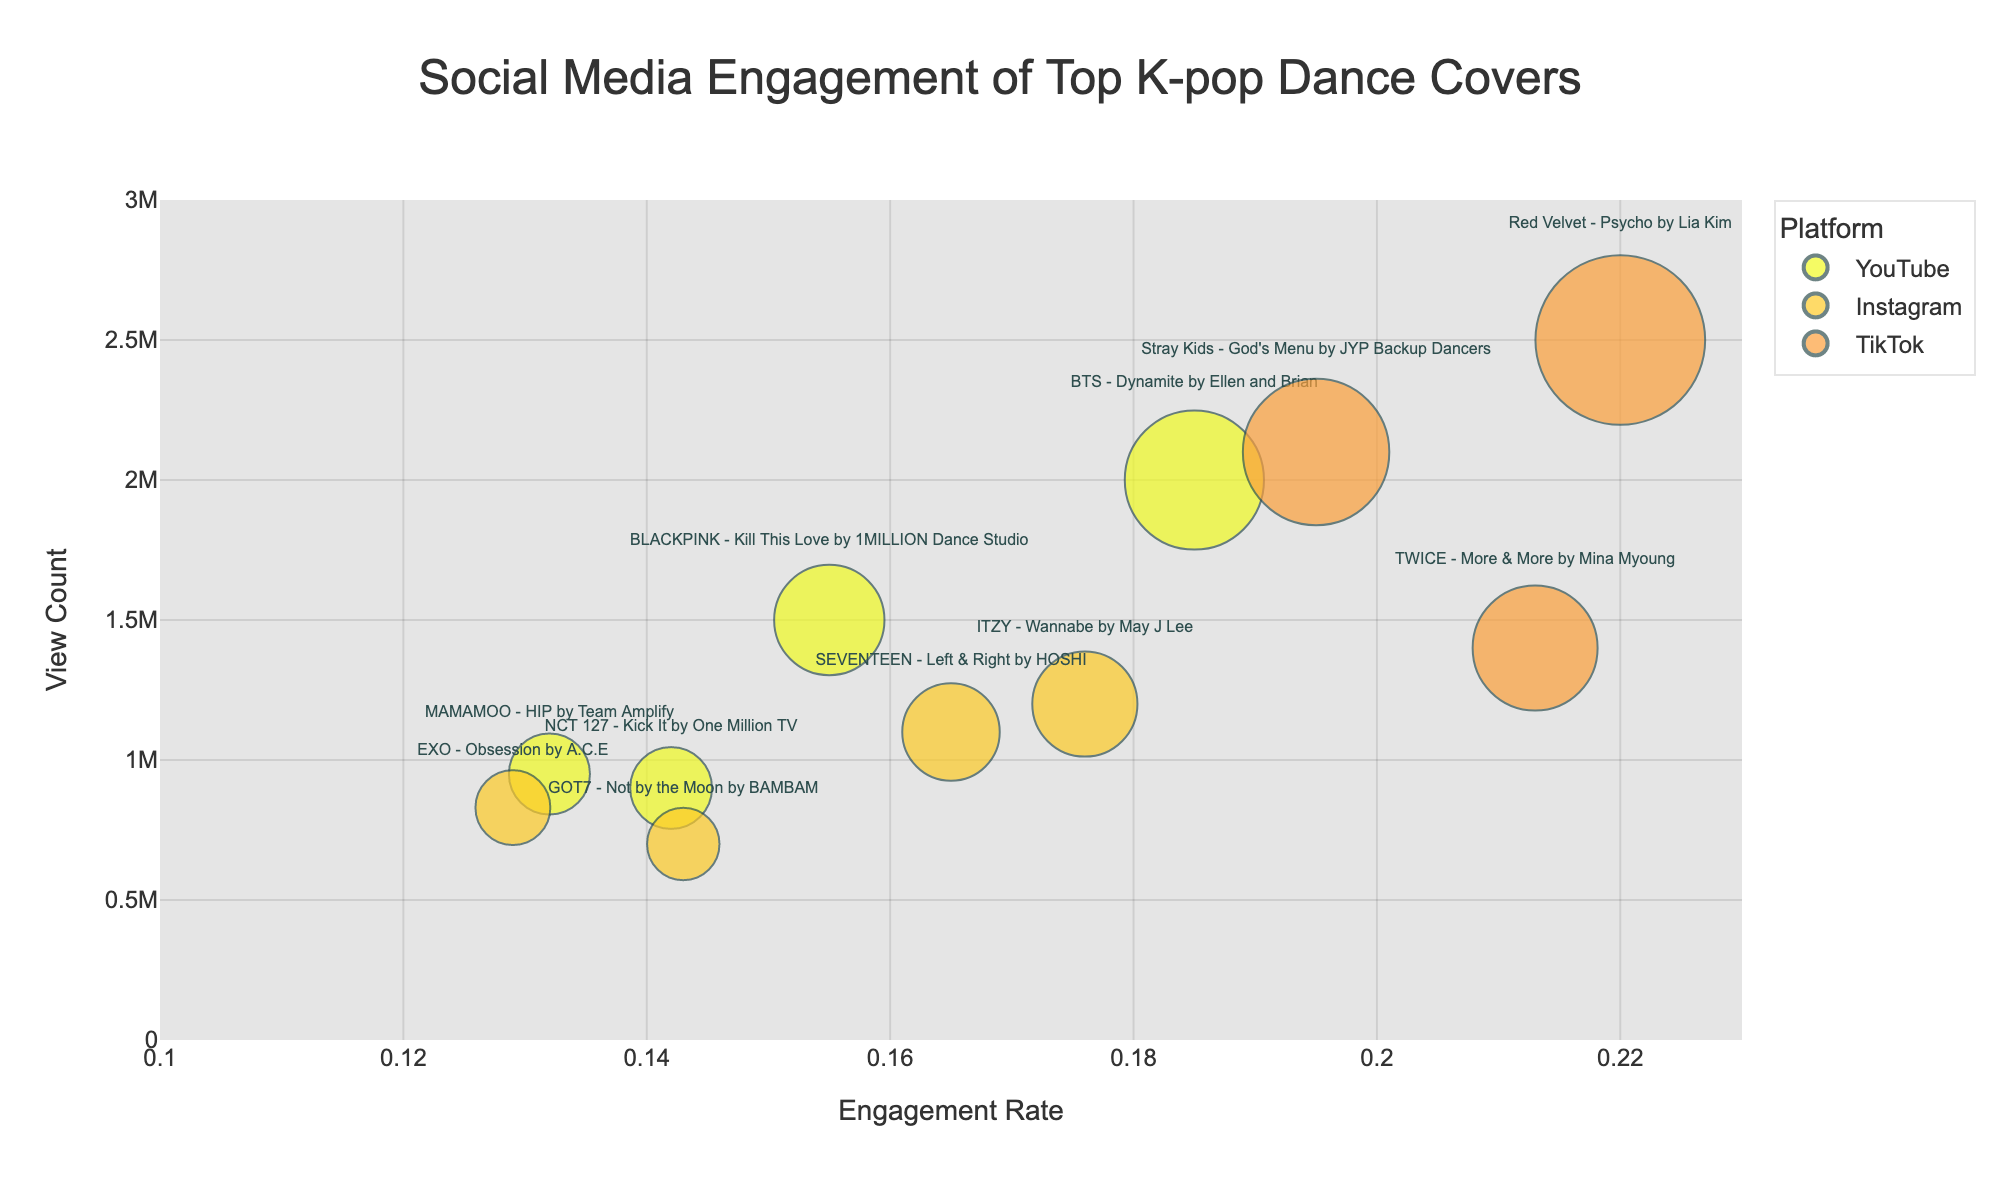What is the title of the bubble chart? The title is usually displayed at the top of the chart, summarizing the content. In this case, it indicates the topic of social media engagement for K-pop dance covers.
Answer: Social Media Engagement of Top K-pop Dance Covers Which platform has the highest engagement rate for a video? The video's highest engagement rate can be identified by finding the largest bubble along the X-axis, as engagement rate is on the X-axis.
Answer: TikTok Which video has the highest view count, and on which platform is it? The highest view count can be identified by the placement of the highest bubble on the Y-axis.
Answer: Red Velvet - Psycho by Lia Kim on TikTok Compare the engagement rates of "BLACKPINK - Kill This Love by 1MILLION Dance Studio" and "MAMAMOO - HIP by Team Amplify". Which one is higher? Locate both bubbles on the X-axis. "BLACKPINK - Kill This Love by 1MILLION Dance Studio" at 0.155 and "MAMAMOO - HIP by Team Amplify" at 0.132. Comparatively, 0.155 is higher.
Answer: BLACKPINK - Kill This Love by 1MILLION Dance Studio Which platform has the bubble with the largest size? Bubble size is shown by the area's size, and TikTok's bubble for "Red Velvet - Psycho by Lia Kim" appears largest.
Answer: TikTok What is the view count range covered by the chart? The Y-axis indicates view counts, which range from 0 up to 3,000,000 as seen from the ticks and the vertical spread of bubbles.
Answer: 0 to 3,000,000 Which video on Instagram has the highest engagement rate, and what is that rate? Identify Instagram videos (color-coding) and find the one furthest on the X-axis. "ITZY - Wannabe by May J Lee" at 0.176.
Answer: ITZY - Wannabe by May J Lee, 0.176 Compare the view counts of "EXO - Obsession by A.C.E" and "NCT 127 - Kick It by One Million TV". Which one is higher? These videos can be found by their names and compared along the Y-axis. "NCT 127 - Kick It by One Million TV" at 900,000 is higher than "EXO - Obsession by A.C.E" at 830,000.
Answer: NCT 127 - Kick It by One Million TV Which platform's videos have the smallest engagement rates? Look for the bubbles closest to the left side on the X-axis. The leftmost bubbles seem to be dominated by YouTube.
Answer: YouTube What is the average engagement rate of videos on YouTube? The engagement rates for YouTube videos are: 0.155, 0.185, 0.142, 0.132. Sum them up (0.155 + 0.185 + 0.142 + 0.132) = 0.614. The average is 0.614 / 4 = 0.1535.
Answer: 0.1535 